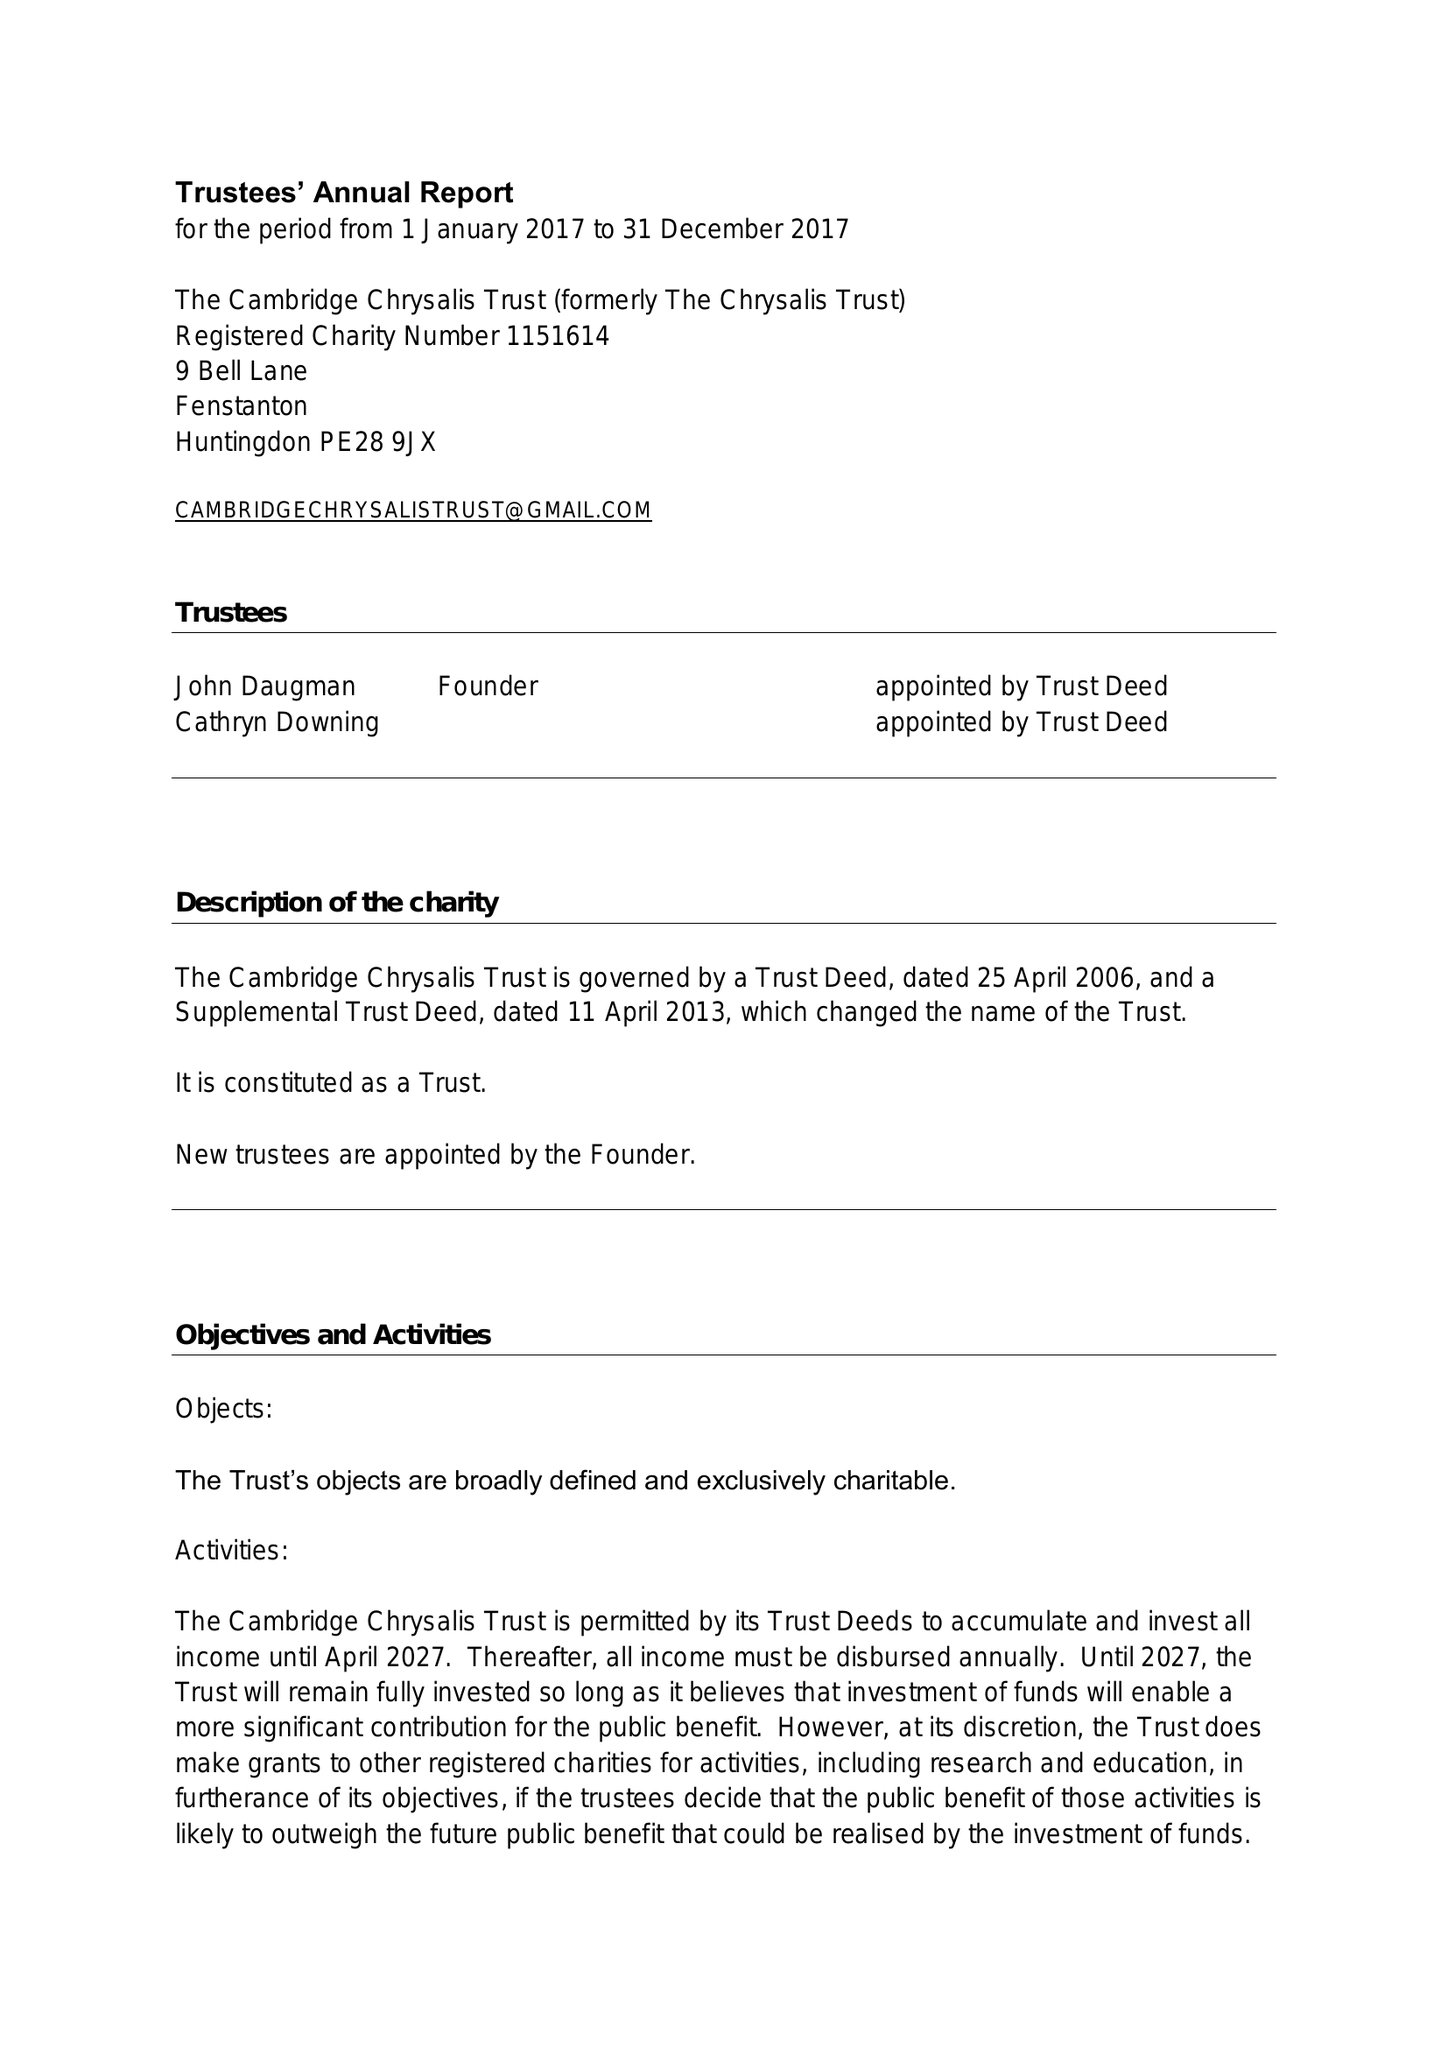What is the value for the spending_annually_in_british_pounds?
Answer the question using a single word or phrase. 260.00 